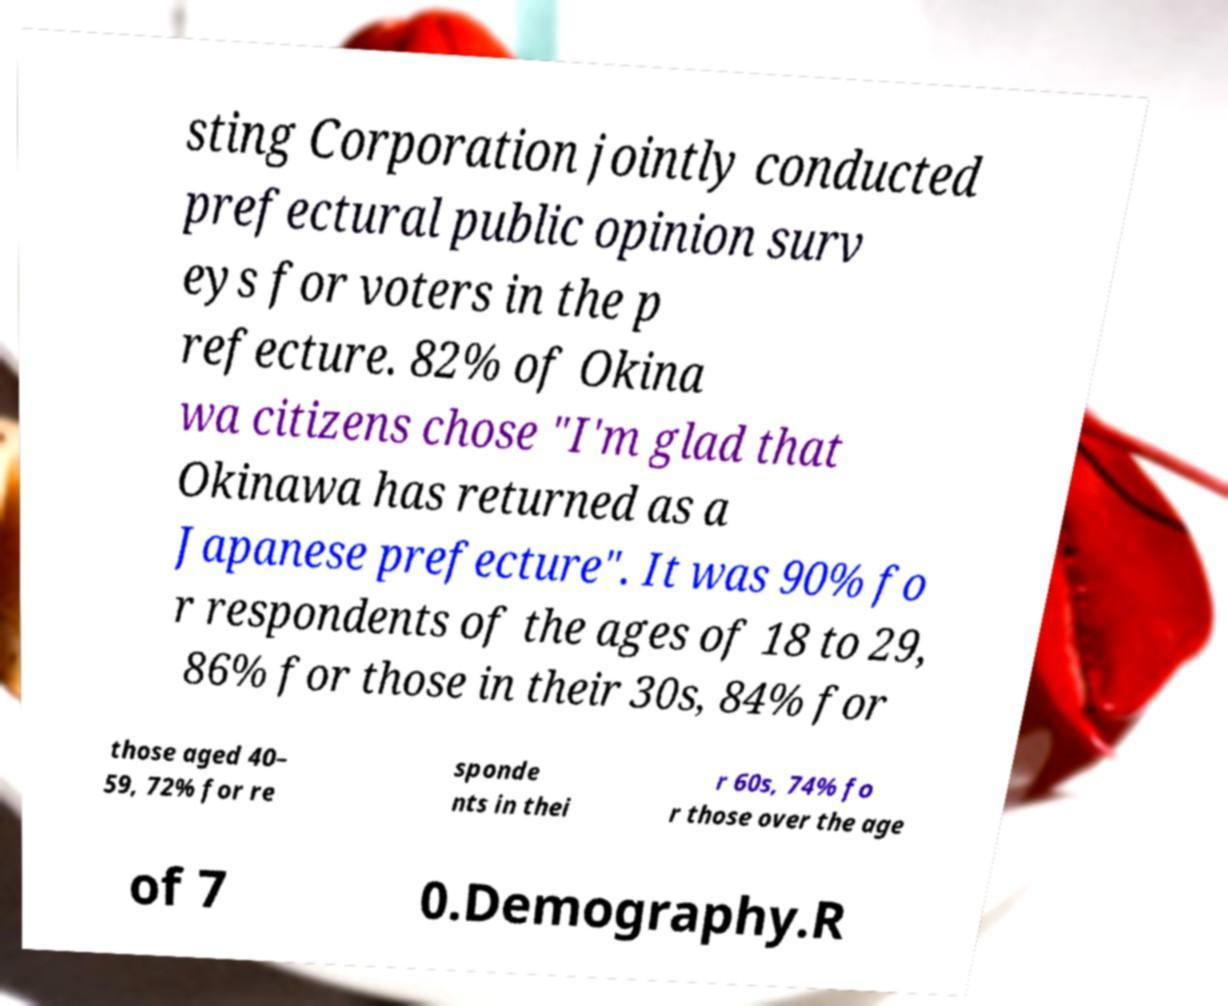Could you extract and type out the text from this image? sting Corporation jointly conducted prefectural public opinion surv eys for voters in the p refecture. 82% of Okina wa citizens chose "I'm glad that Okinawa has returned as a Japanese prefecture". It was 90% fo r respondents of the ages of 18 to 29, 86% for those in their 30s, 84% for those aged 40– 59, 72% for re sponde nts in thei r 60s, 74% fo r those over the age of 7 0.Demography.R 